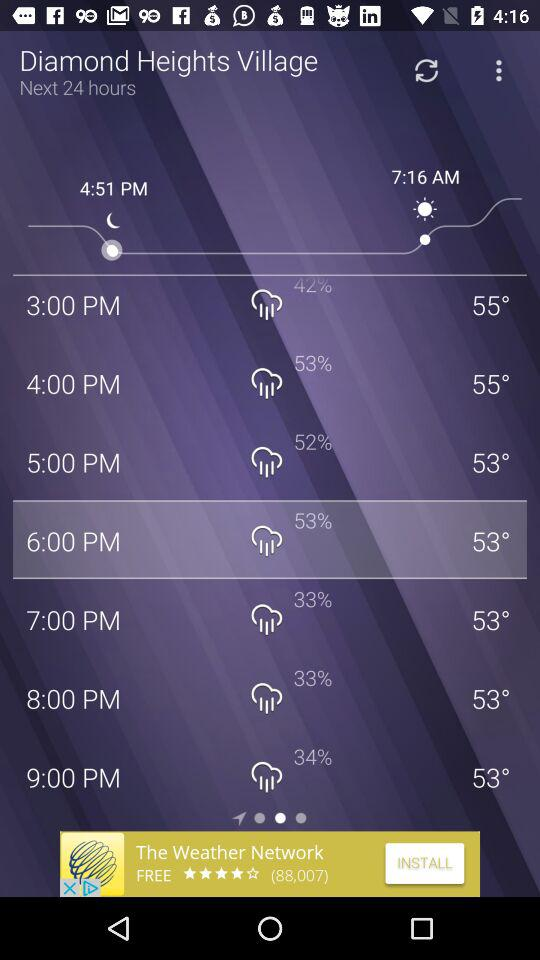At what time is there a 34% probability of rain? There is a 34% probability of rain at 9 p.m. 